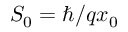Convert formula to latex. <formula><loc_0><loc_0><loc_500><loc_500>S _ { 0 } = \hbar { / } q x _ { 0 }</formula> 